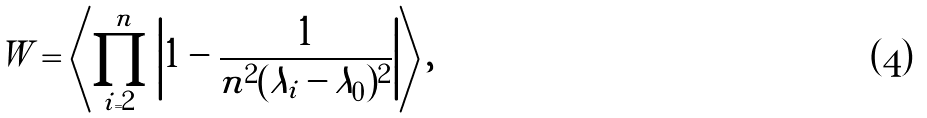Convert formula to latex. <formula><loc_0><loc_0><loc_500><loc_500>W = \left \langle \prod _ { i = 2 } ^ { n } \left | 1 - { \frac { 1 } { n ^ { 2 } ( \lambda _ { i } - \lambda _ { 0 } ) ^ { 2 } } } \right | \right \rangle ,</formula> 